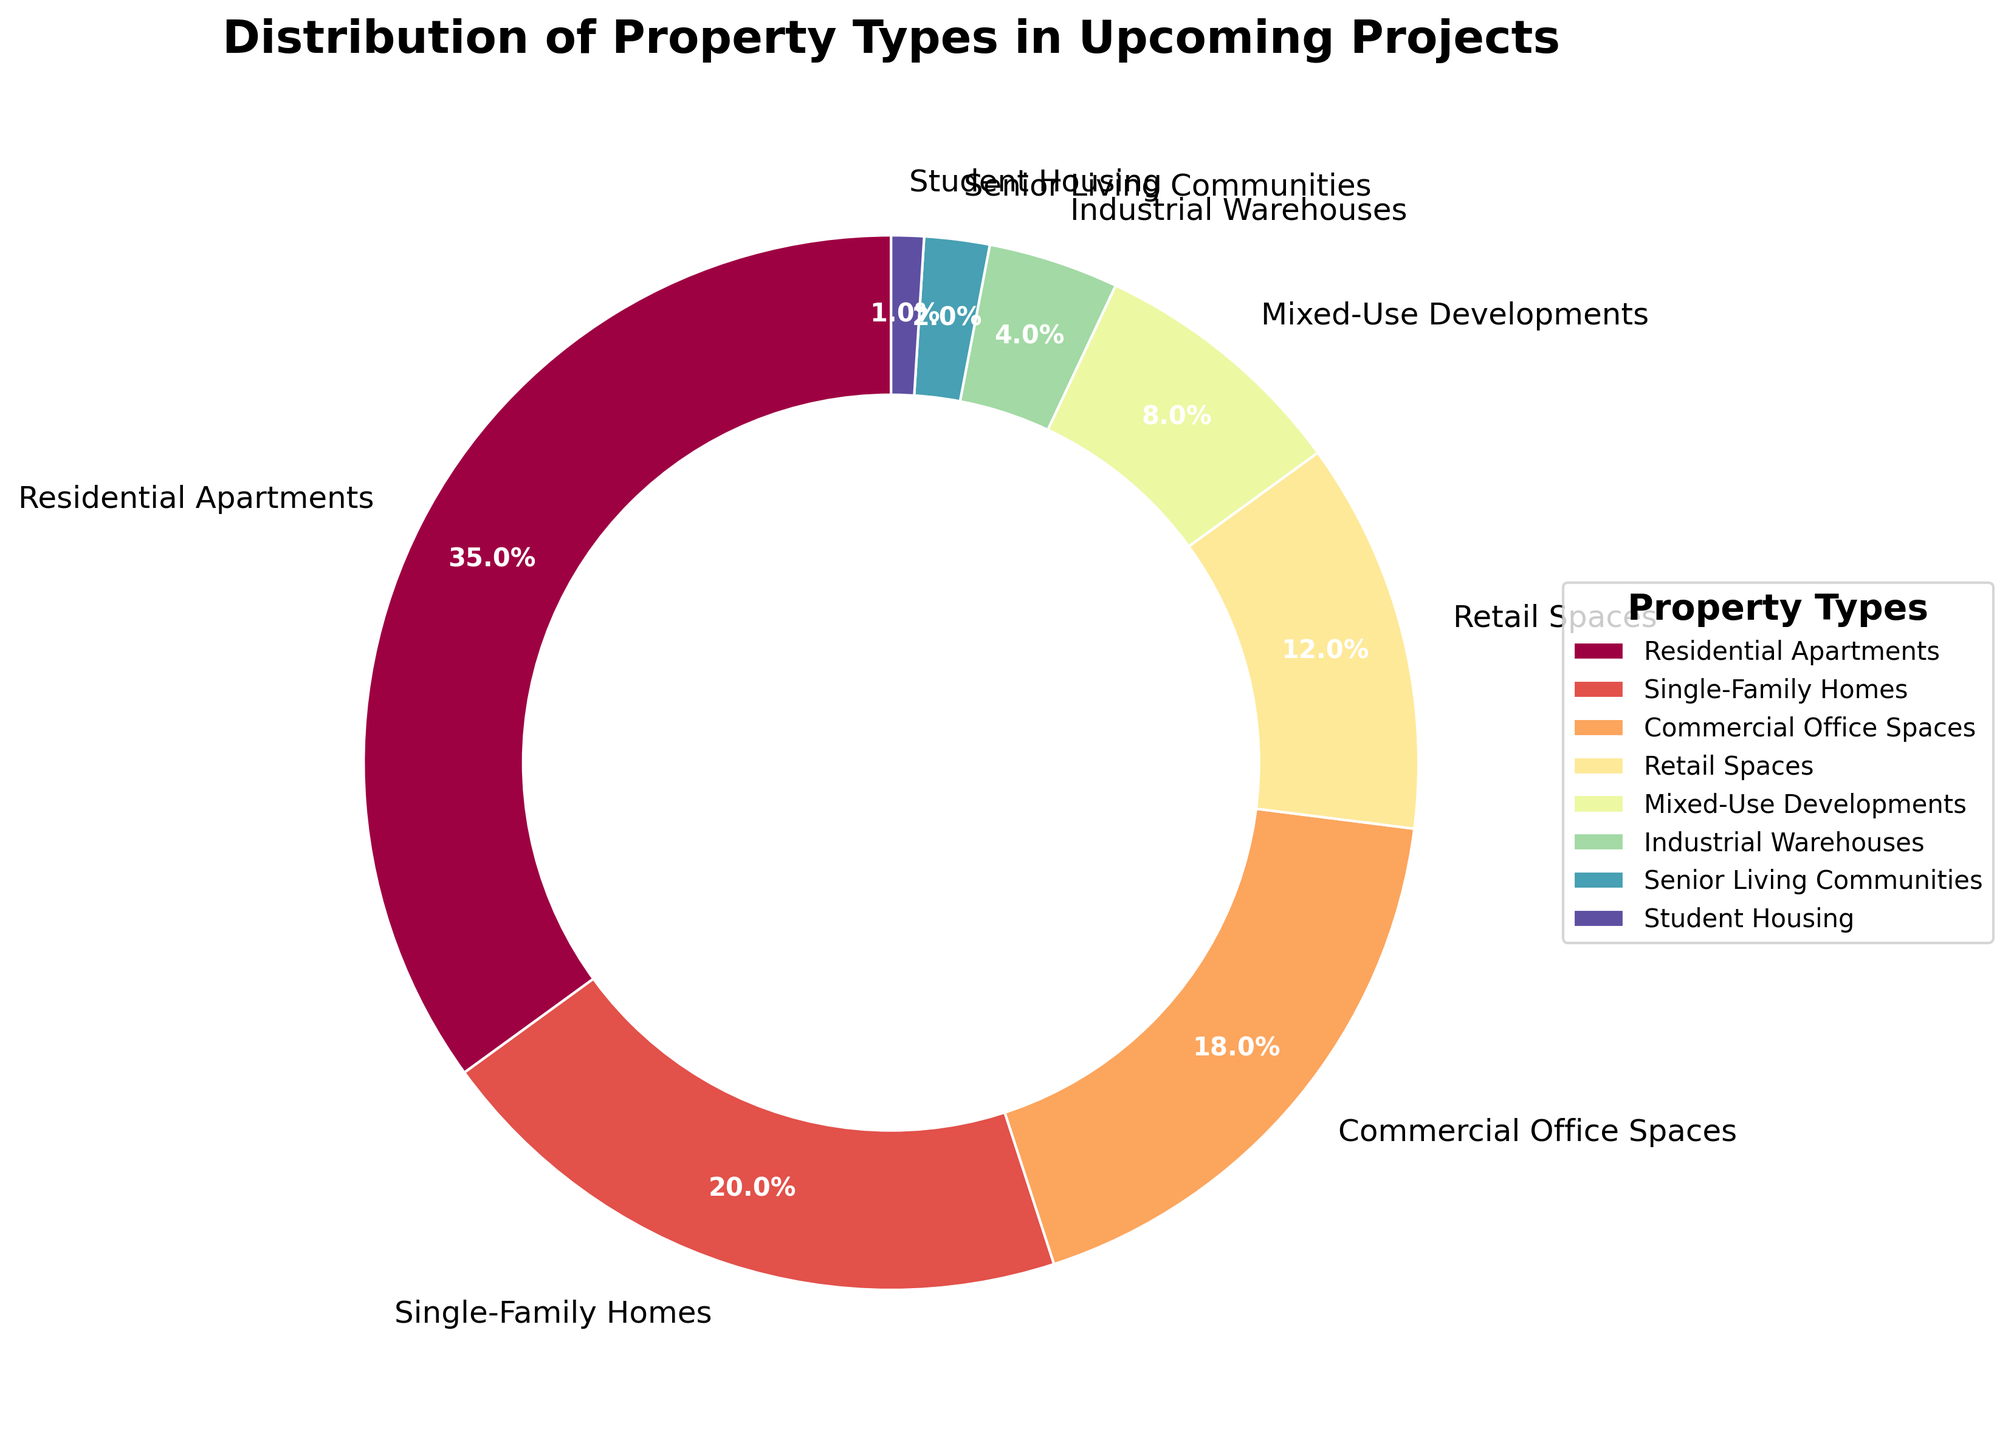What percentage of the upcoming projects are dedicated to residential property types (both Residential Apartments and Single-Family Homes)? To find this, we need to sum the percentages of Residential Apartments (35%) and Single-Family Homes (20%). The total percentage for residential property types is 35% + 20% = 55%.
Answer: 55% Which property type has a higher percentage, Commercial Office Spaces or Retail Spaces? By how much? Commercial Office Spaces have a percentage of 18%, while Retail Spaces have a percentage of 12%. To find the difference, we subtract 12% from 18%, which results in 6%.
Answer: Commercial Office Spaces by 6% What property type accounts for the smallest percentage of the upcoming projects? Observing the slices in the pie chart and the corresponding percentages, Student Housing has the smallest percentage at 1%.
Answer: Student Housing What is the combined percentage of Mixed-Use Developments, Industrial Warehouses, and Senior Living Communities? We need to sum the percentages of Mixed-Use Developments (8%), Industrial Warehouses (4%), and Senior Living Communities (2%). The total combined percentage is 8% + 4% + 2% = 14%.
Answer: 14% Is the percentage of Residential Apartments alone greater than the combined percentage of Industrial Warehouses, Senior Living Communities, and Student Housing? Residential Apartments account for 35%. The combined percentage of Industrial Warehouses (4%), Senior Living Communities (2%), and Student Housing (1%) is 4% + 2% + 1% = 7%. Since 35% > 7%, the percentage of Residential Apartments alone is greater.
Answer: Yes What color is the wedge representing Retail Spaces in the pie chart? Referring to the visual attribute of the wedge for Retail Spaces, it can be identified by its unique color among other wedges. In the pie chart settings, the colors cover a range of visually distinct hues from the spectral palette.
Answer: (Provide the visual color as seen in the pie chart like red, blue etc.) How much larger is the Industrial Warehouses percentage compared to Student Housing in the upcoming projects? The percentage for Industrial Warehouses is 4%, while for Student Housing it is 1%. To find the difference, we subtract 1% from 4%, resulting in 3%.
Answer: 3% If we were to represent only Commercial properties (Office Spaces and Retail Spaces) in the pie chart, what would be their combined percentage? To find this, we need to sum the percentages of Commercial Office Spaces (18%) and Retail Spaces (12%). The combined percentage is 18% + 12% = 30%.
Answer: 30% 